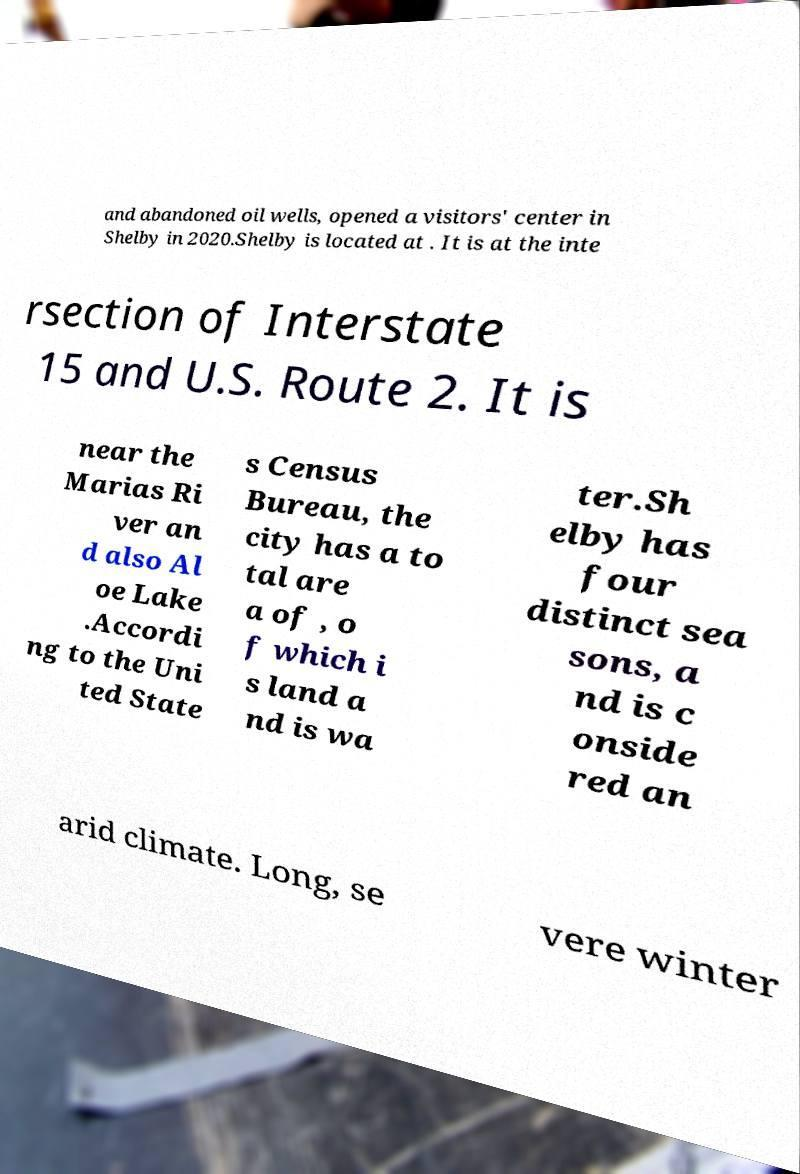Please identify and transcribe the text found in this image. and abandoned oil wells, opened a visitors' center in Shelby in 2020.Shelby is located at . It is at the inte rsection of Interstate 15 and U.S. Route 2. It is near the Marias Ri ver an d also Al oe Lake .Accordi ng to the Uni ted State s Census Bureau, the city has a to tal are a of , o f which i s land a nd is wa ter.Sh elby has four distinct sea sons, a nd is c onside red an arid climate. Long, se vere winter 